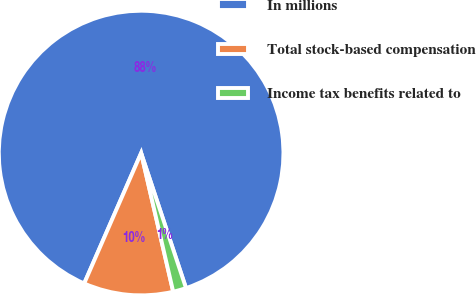Convert chart to OTSL. <chart><loc_0><loc_0><loc_500><loc_500><pie_chart><fcel>In millions<fcel>Total stock-based compensation<fcel>Income tax benefits related to<nl><fcel>88.34%<fcel>10.17%<fcel>1.49%<nl></chart> 